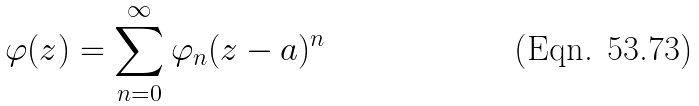<formula> <loc_0><loc_0><loc_500><loc_500>\varphi ( z ) = \sum _ { n = 0 } ^ { \infty } \varphi _ { n } ( z - a ) ^ { n }</formula> 